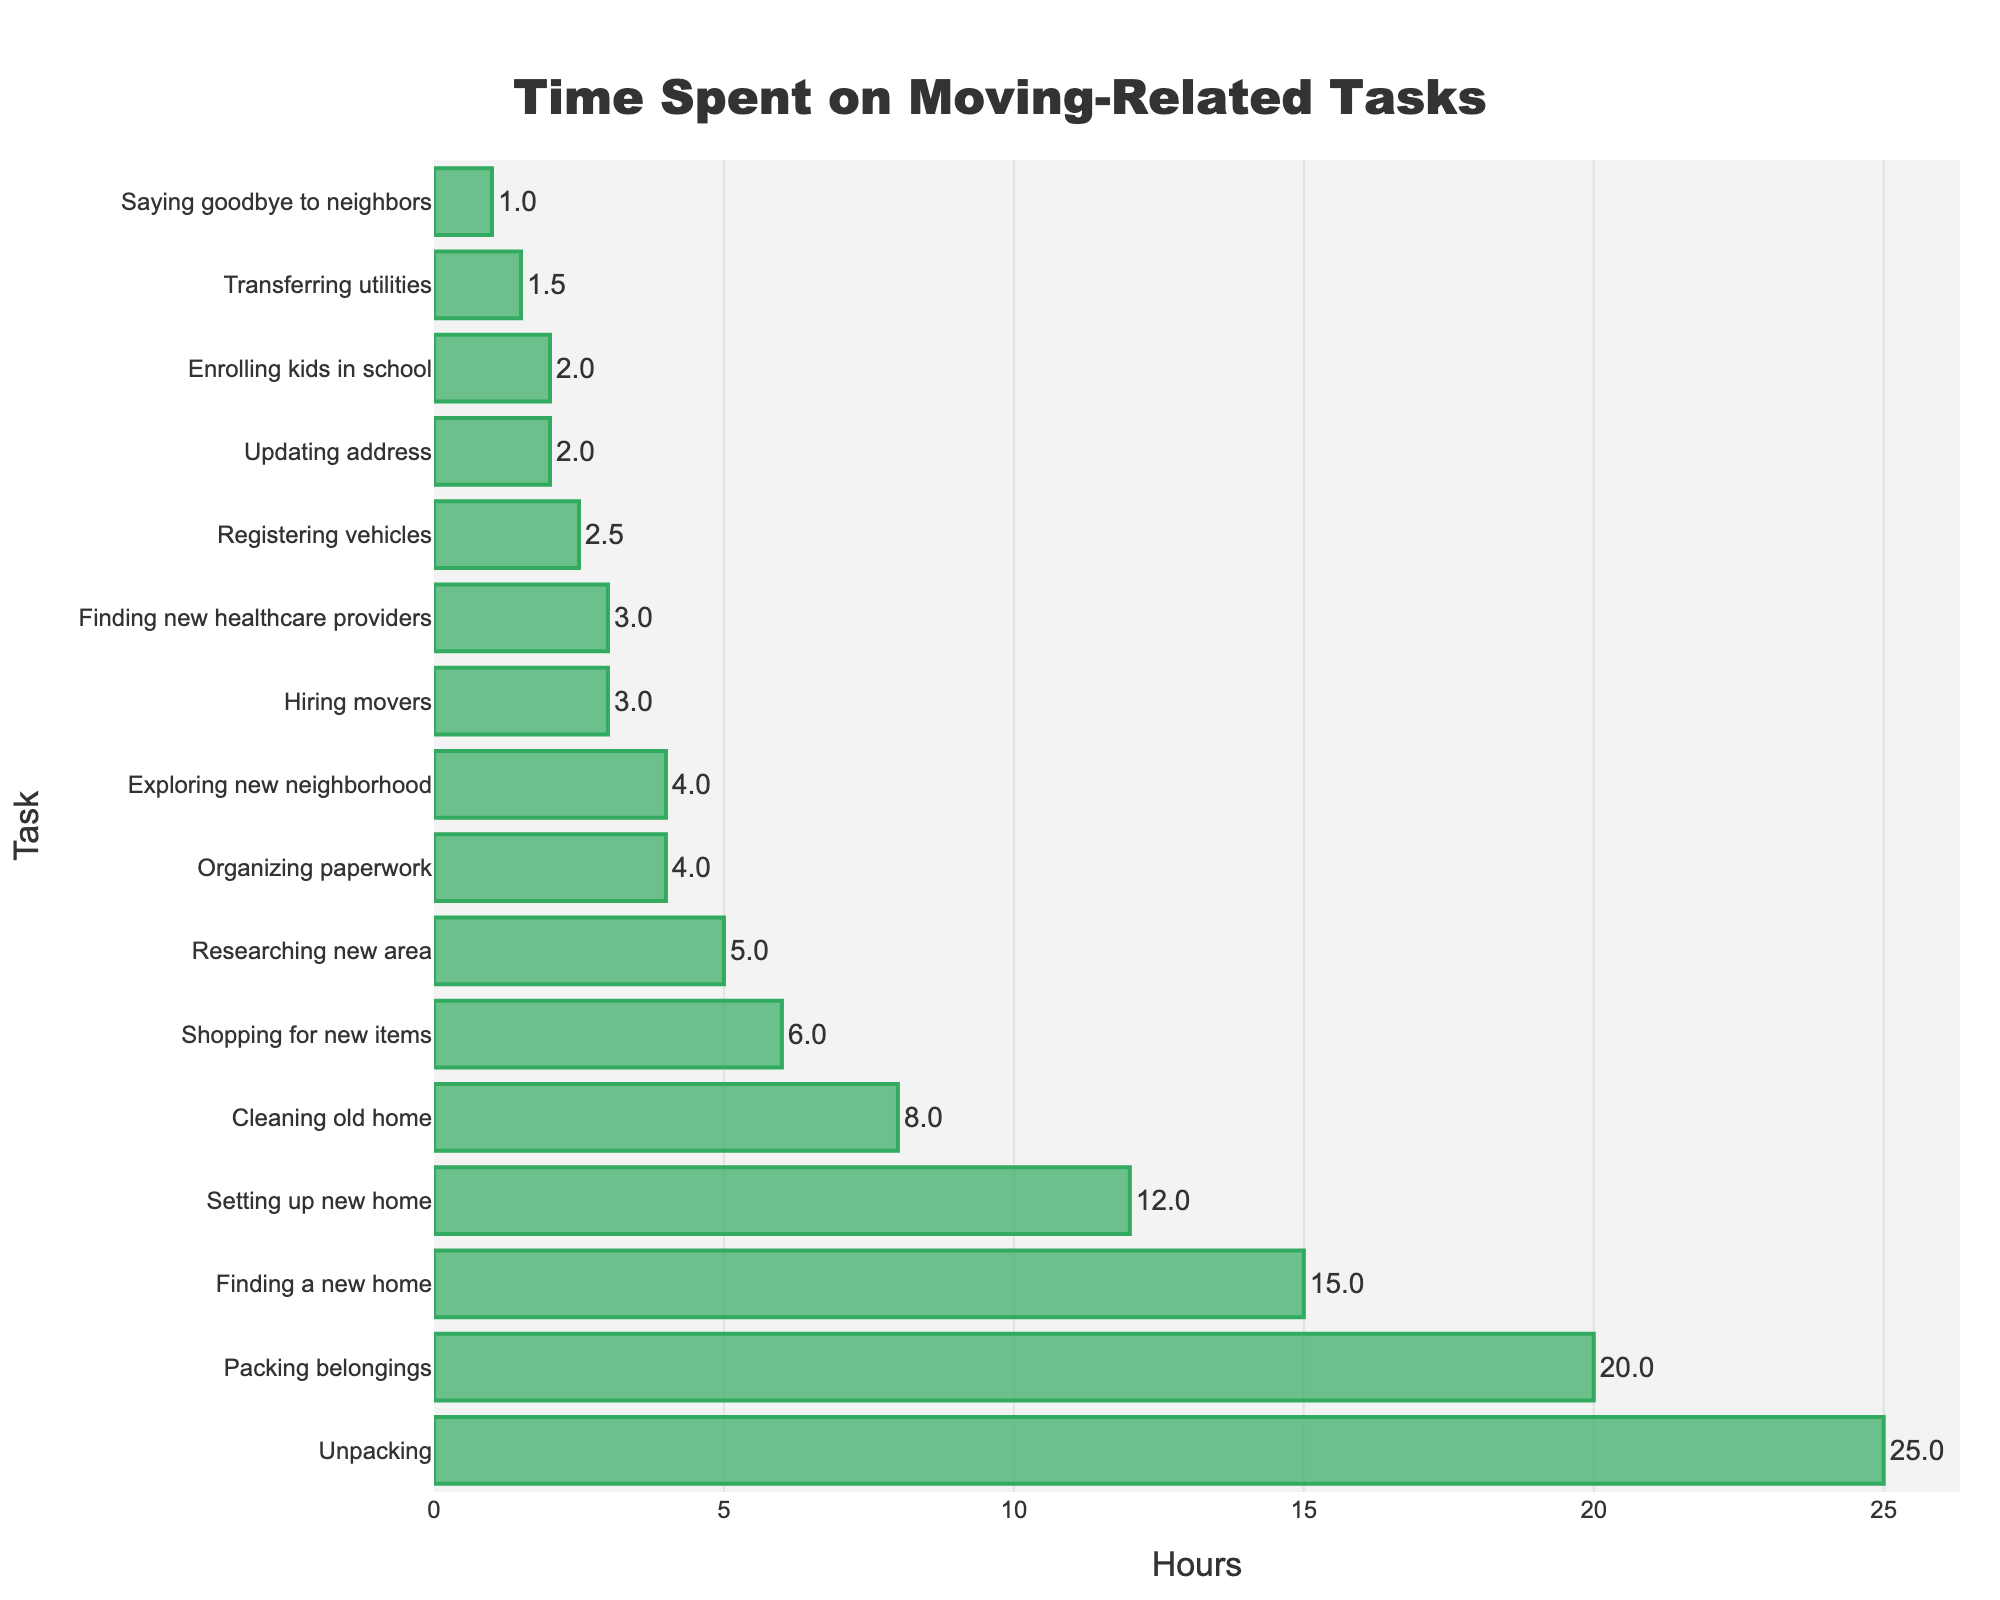What is the task on which you spent the most time? The task with the longest bar in the chart represents the one you spent the most time on. From the chart, "Unpacking" has the longest bar, indicating you spent the most time on it.
Answer: Unpacking How many hours did you spend on packing belongings and unpacking combined? Add the hours spent on "Packing belongings" and "Unpacking." According to the chart, packing belongings took 20 hours and unpacking took 25 hours, so 20 + 25 = 45 hours.
Answer: 45 hours Which task took more time: Finding a new home or Setting up the new home? Compare the bar lengths for "Finding a new home" and "Setting up the new home." The chart shows that finding a new home took 15 hours whereas setting up the new home took 12 hours. Therefore, finding a new home took more time.
Answer: Finding a new home Which tasks took exactly 4 hours each? Identify the tasks with bars that correspond to 4 hours. The chart shows that "Organizing paperwork" and "Exploring new neighborhood" each took 4 hours.
Answer: Organizing paperwork, Exploring new neighborhood How much more time did you spend on Shopping for new items than Updating address? Subtract the hours spent on "Updating address" from "Shopping for new items." According to the chart, shopping for new items took 6 hours and updating address took 2 hours, so 6 - 2 = 4 hours.
Answer: 4 hours What is the total time spent on tasks that took 2 hours or less? Add the hours for tasks that took 2 hours or less: "Updating address" (2 hours), "Transferring utilities" (1.5 hours), "Saying goodbye to neighbors" (1 hour), and "Enrolling kids in school" (2 hours). 2 + 1.5 + 1 + 2 = 6.5 hours.
Answer: 6.5 hours Which tasks took less than 3 hours? Identify the tasks with bars representing less than 3 hours. From the chart, these tasks are: "Updating address" (2 hours), "Transferring utilities" (1.5 hours), "Saying goodbye to neighbors" (1 hour), "Registering vehicles" (2.5 hours), and "Enrolling kids in school" (2 hours).
Answer: Updating address, Transferring utilities, Saying goodbye to neighbors, Registering vehicles, Enrolling kids in school 